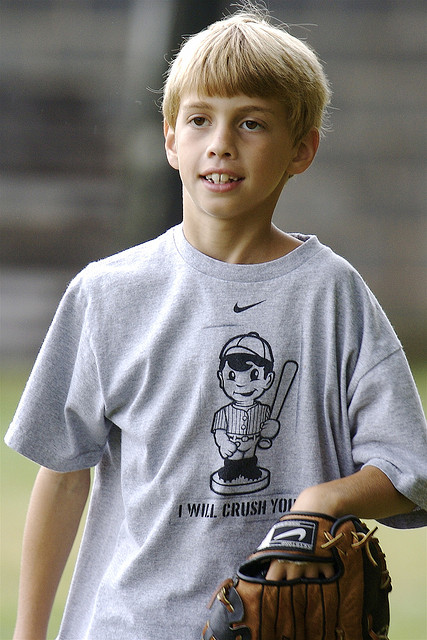Extract all visible text content from this image. I WILL CRUSH YOV 